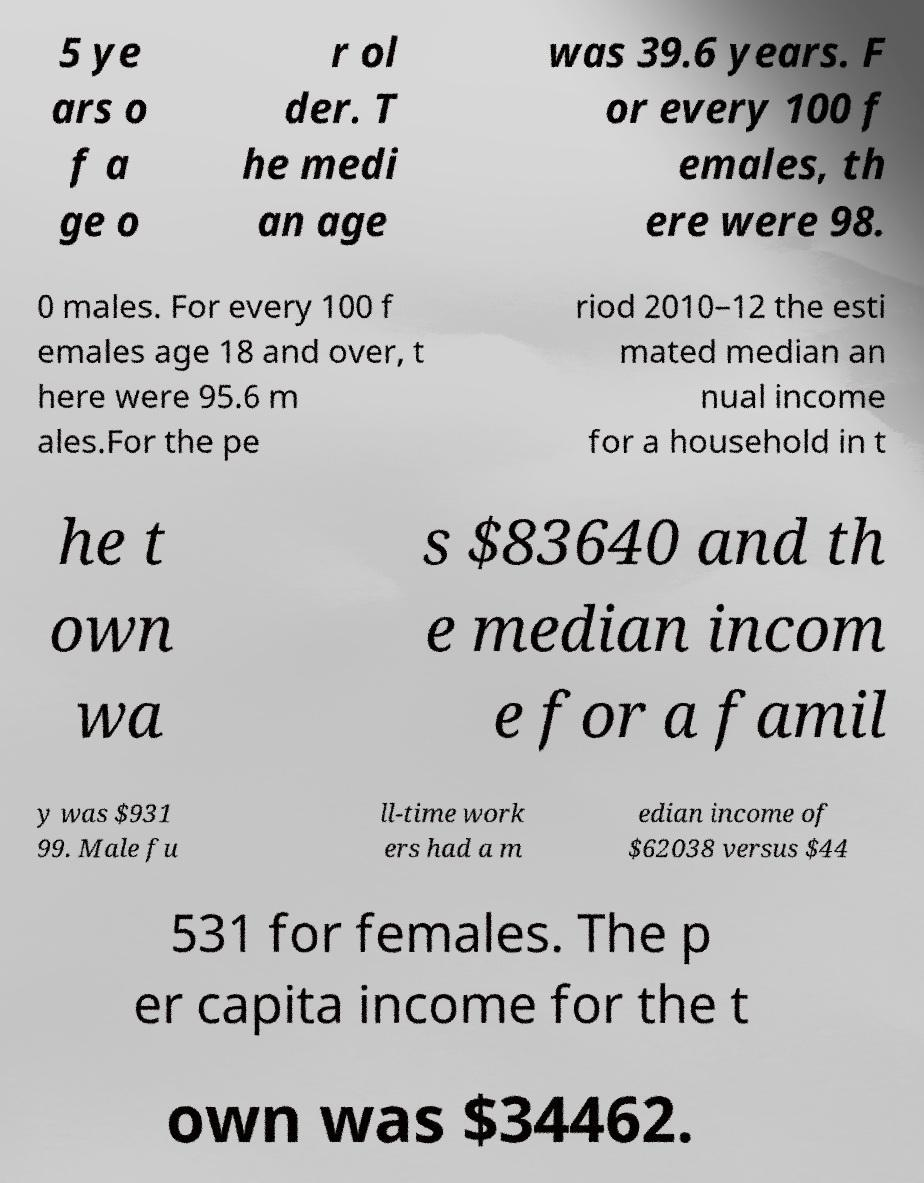I need the written content from this picture converted into text. Can you do that? 5 ye ars o f a ge o r ol der. T he medi an age was 39.6 years. F or every 100 f emales, th ere were 98. 0 males. For every 100 f emales age 18 and over, t here were 95.6 m ales.For the pe riod 2010–12 the esti mated median an nual income for a household in t he t own wa s $83640 and th e median incom e for a famil y was $931 99. Male fu ll-time work ers had a m edian income of $62038 versus $44 531 for females. The p er capita income for the t own was $34462. 